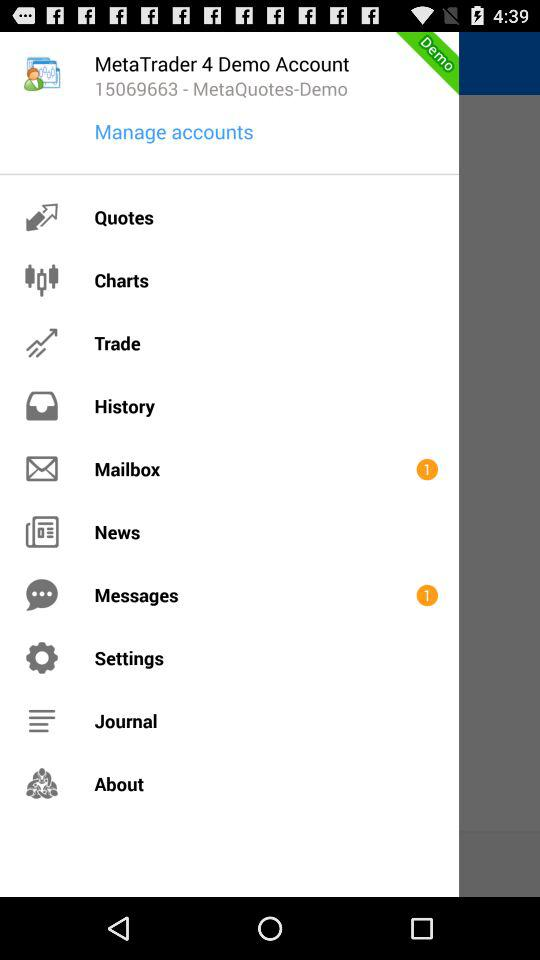Are there any unread messages? There is one unread message. 